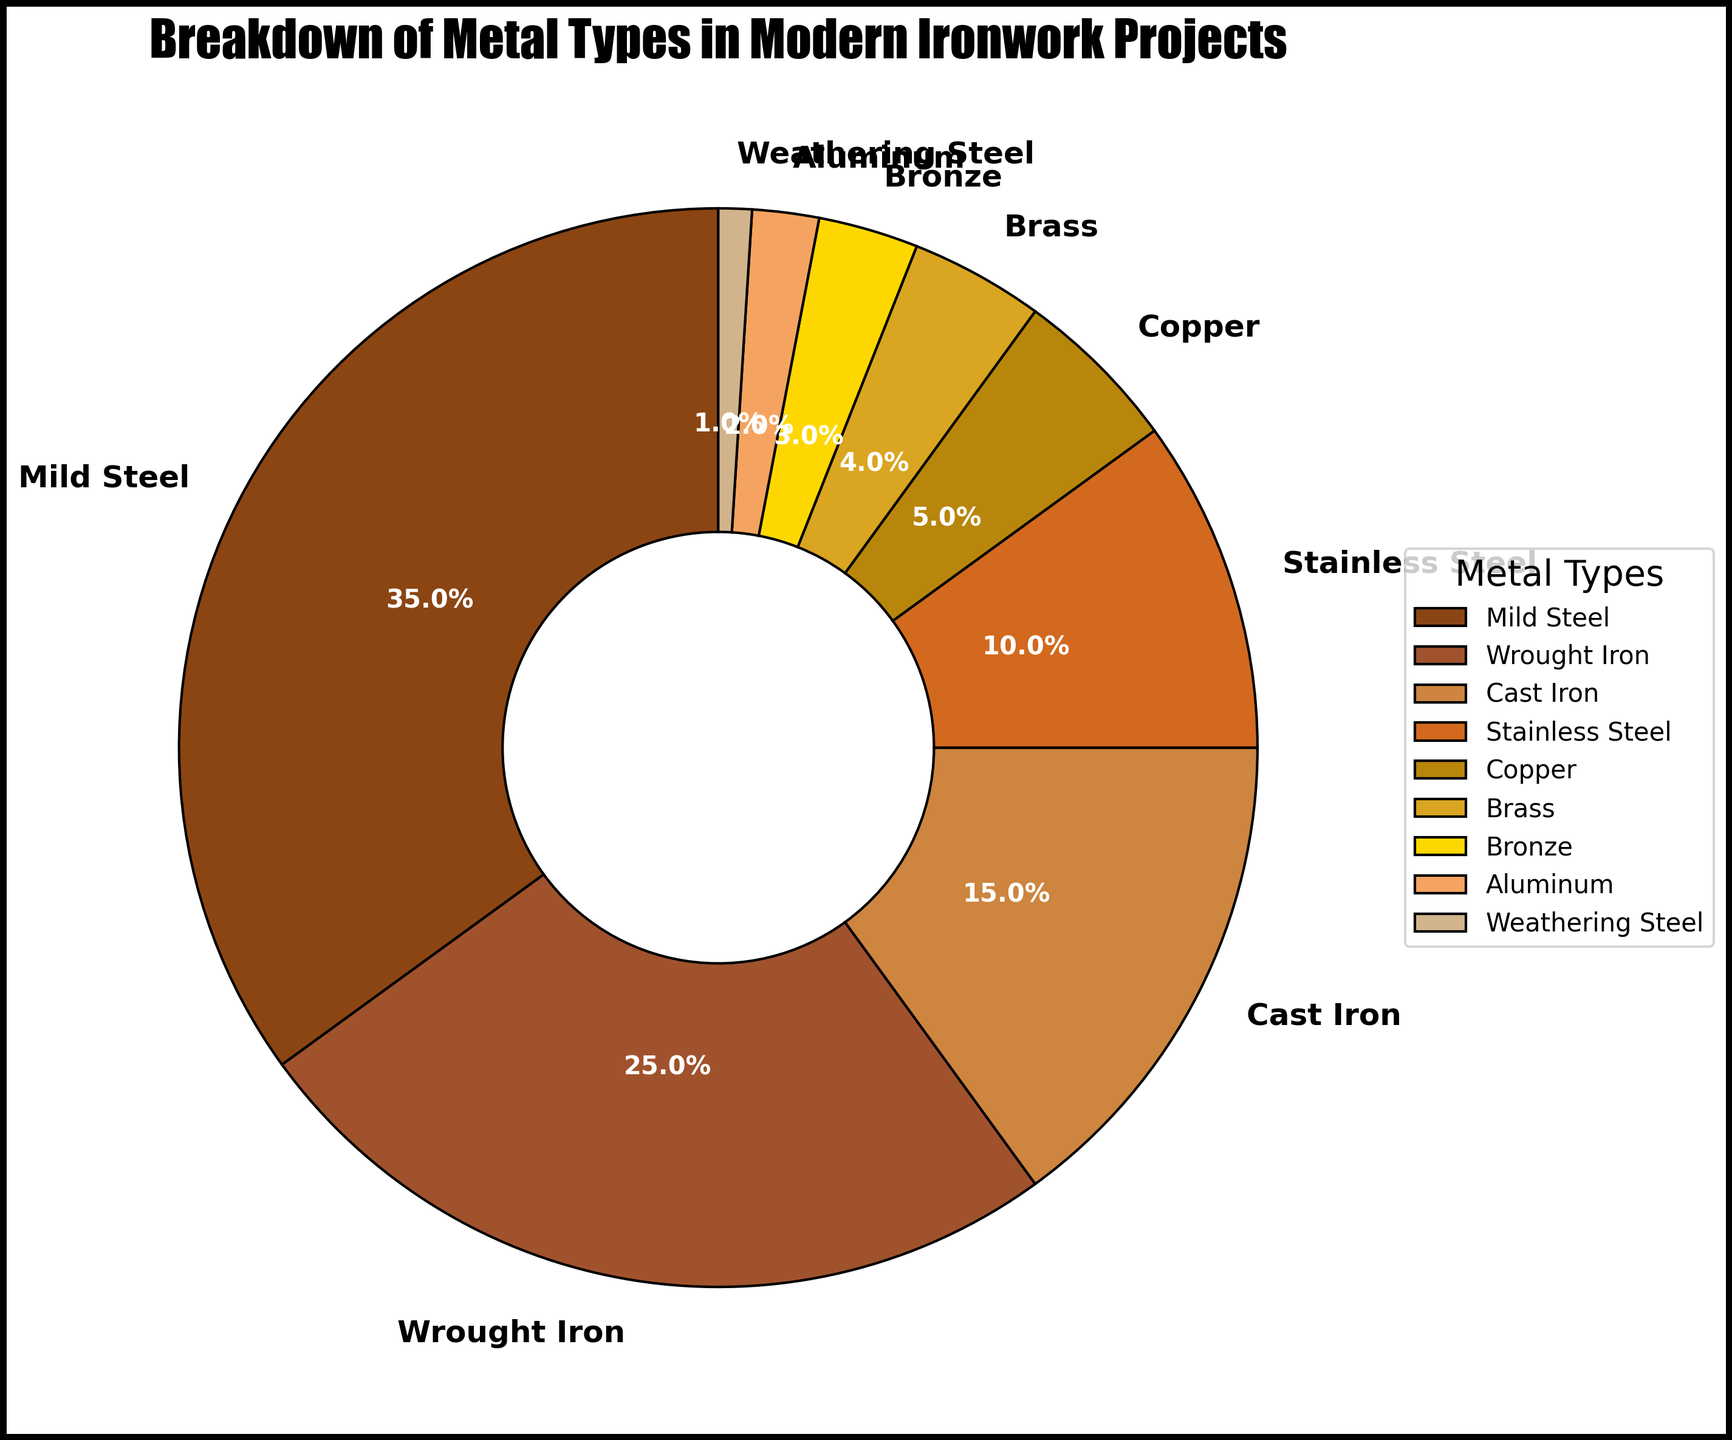What is the most commonly used metal type in modern ironwork projects? The pie chart shows that Mild Steel takes up the largest segment at 35%, making it the most commonly used metal type.
Answer: Mild Steel How does the usage of Wrought Iron compare to the usage of Cast Iron? The pie chart indicates that Wrought Iron is used more (25%) compared to Cast Iron (15%). This shows that Wrought Iron is utilized 10% more than Cast Iron.
Answer: Wrought Iron is used more Which metal type forms the smallest segment in the pie chart? By examining the pie chart, it is apparent that Weathering Steel has the smallest portion, accounting for only 1% of the metals used.
Answer: Weathering Steel What is the combined percentage of Copper and Brass used in the projects? The pie chart indicates that Copper accounts for 5% and Brass for 4%. Adding these percentages together gives 5% + 4% = 9%.
Answer: 9% If you combine the percentages of Bronze and Aluminum, is the total greater than the percentage of Stainless Steel? The pie chart shows Bronze at 3% and Aluminum at 2%, which adds up to 5%. This is less than Stainless Steel, which is 10%.
Answer: No Which metals are represented by warmer colors like brown and gold tones in the pie chart? The visual inspection of the pie chart shows that metals like Copper, Brass, and Bronze are represented by warmer colors, reflective of their natural hues.
Answer: Copper, Brass, Bronze What is the total percentage of metals that are not steel-based? The non-steel metals listed are Copper (5%), Brass (4%), Bronze (3%), and Aluminum (2%), and Weathering Steel (1%), which sum up to 5 + 4 + 3 + 2 + 1 = 15%.
Answer: 15% How does the percentage of Stainless Steel compare to the combined percentage of Wrought Iron and Cast Iron? Wrought Iron is at 25% and Cast Iron at 15%. Their combined percentage is 25% + 15% = 40%, which is much higher than Stainless Steel at 10%.
Answer: Wrought Iron and Cast Iron combined are higher What fraction of the entire pie chart is occupied by the top three metals? The top three metals are Mild Steel (35%), Wrought Iron (25%), and Cast Iron (15%). Their combined percentage is 35% + 25% + 15% = 75%, which is (3/4) of the pie chart.
Answer: 3/4 What is the difference in percentage between the highest and lowest used metal types? Mild Steel has the highest usage at 35%, while Weathering Steel has the lowest at 1%. The difference in their percentage is 35% - 1% = 34%.
Answer: 34% 